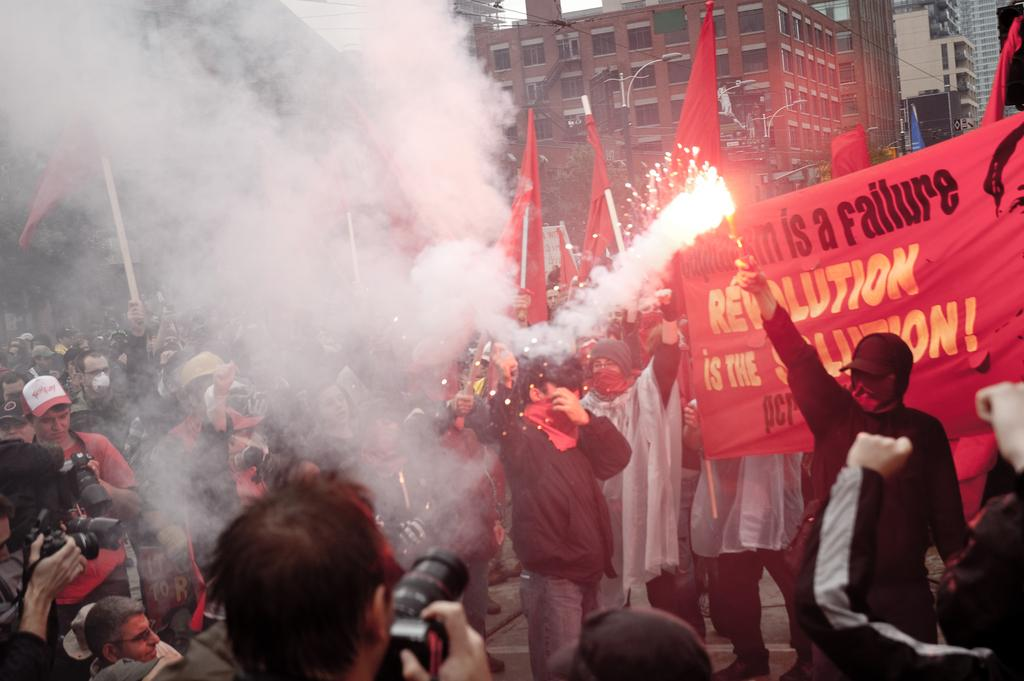<image>
Relay a brief, clear account of the picture shown. People protesting and holding a sign that says Revolution. 